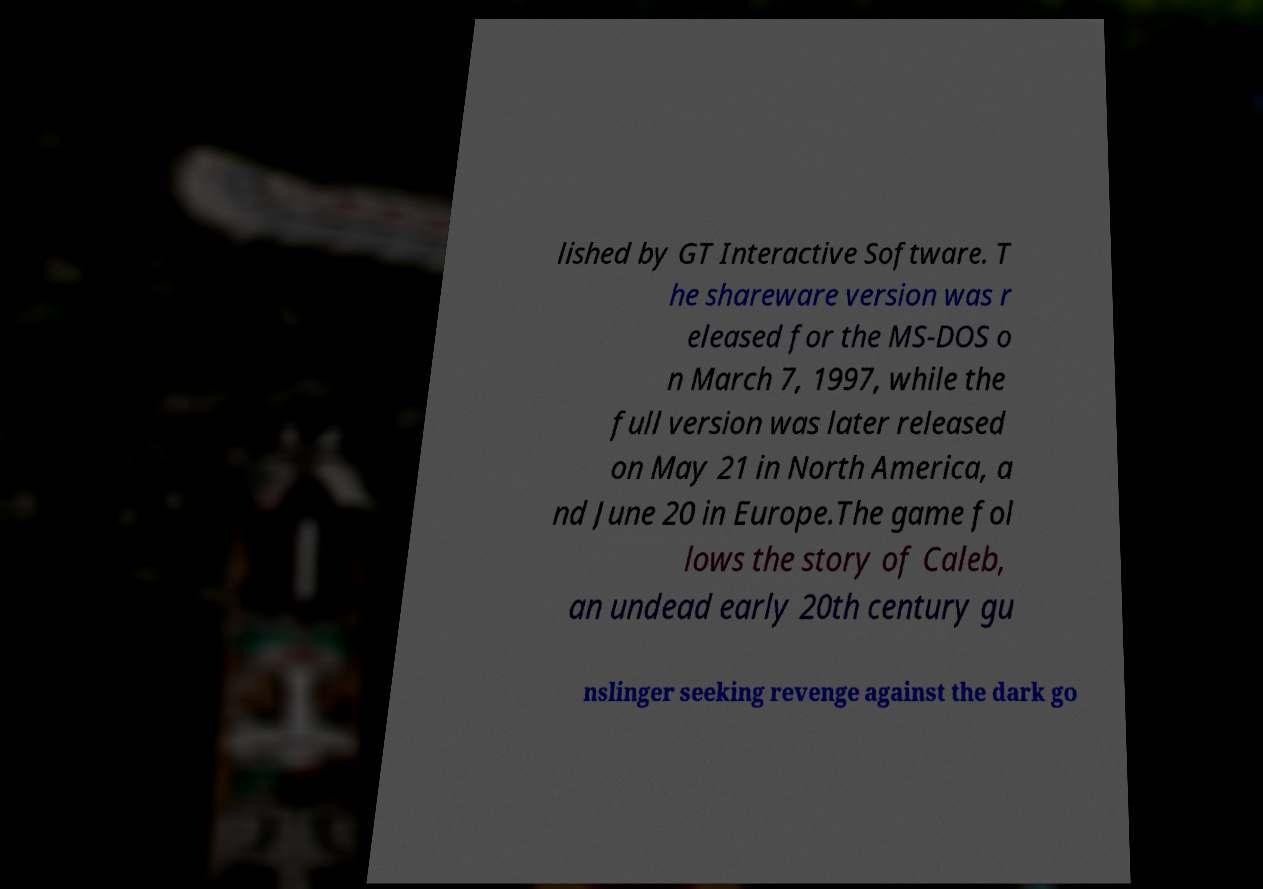Could you extract and type out the text from this image? lished by GT Interactive Software. T he shareware version was r eleased for the MS-DOS o n March 7, 1997, while the full version was later released on May 21 in North America, a nd June 20 in Europe.The game fol lows the story of Caleb, an undead early 20th century gu nslinger seeking revenge against the dark go 